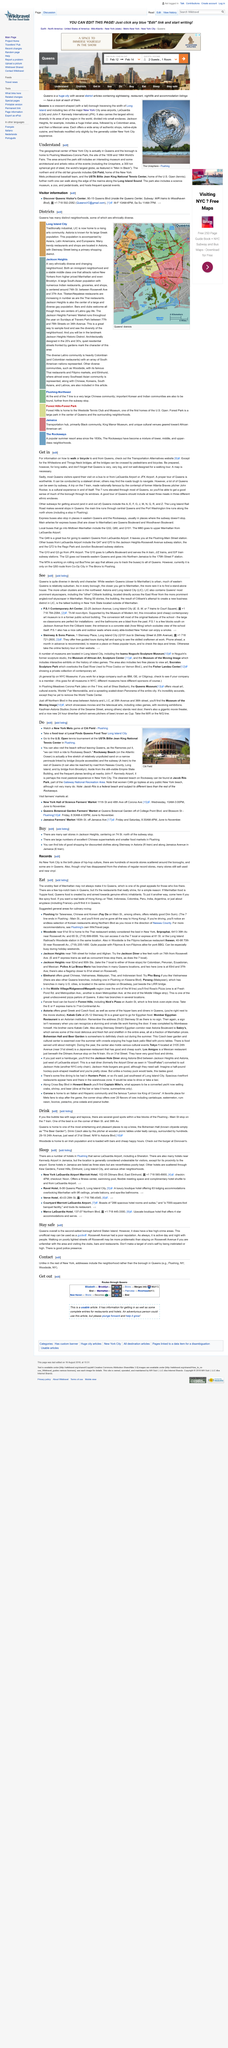Identify some key points in this picture. Kennedy Airport in Jamaica is considered undesirable due to its location. The best bubble tea can be found at the corner of Main St. and 39th Av. Queens is a destination that offers some of the most enjoyable and delightful experiences for beer enthusiasts, making it one of the most entertaining and enjoyable places to sip brew. The method of transportation not mentioned in the article is: Boat. Queens is a diverse and vibrant borough with a rich cultural heritage. A good tour of Queens should include a visit to several ethnic enclaves to get a true sense of the borough's unique character. According to some estimates, there are at least three ethnic enclaves that any such tour should not miss. 